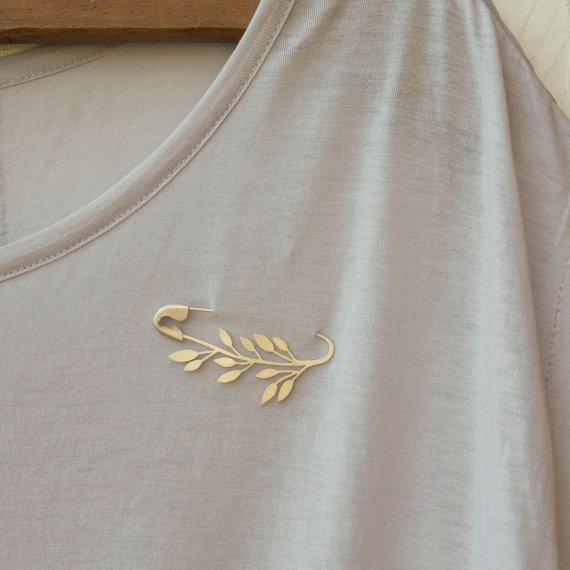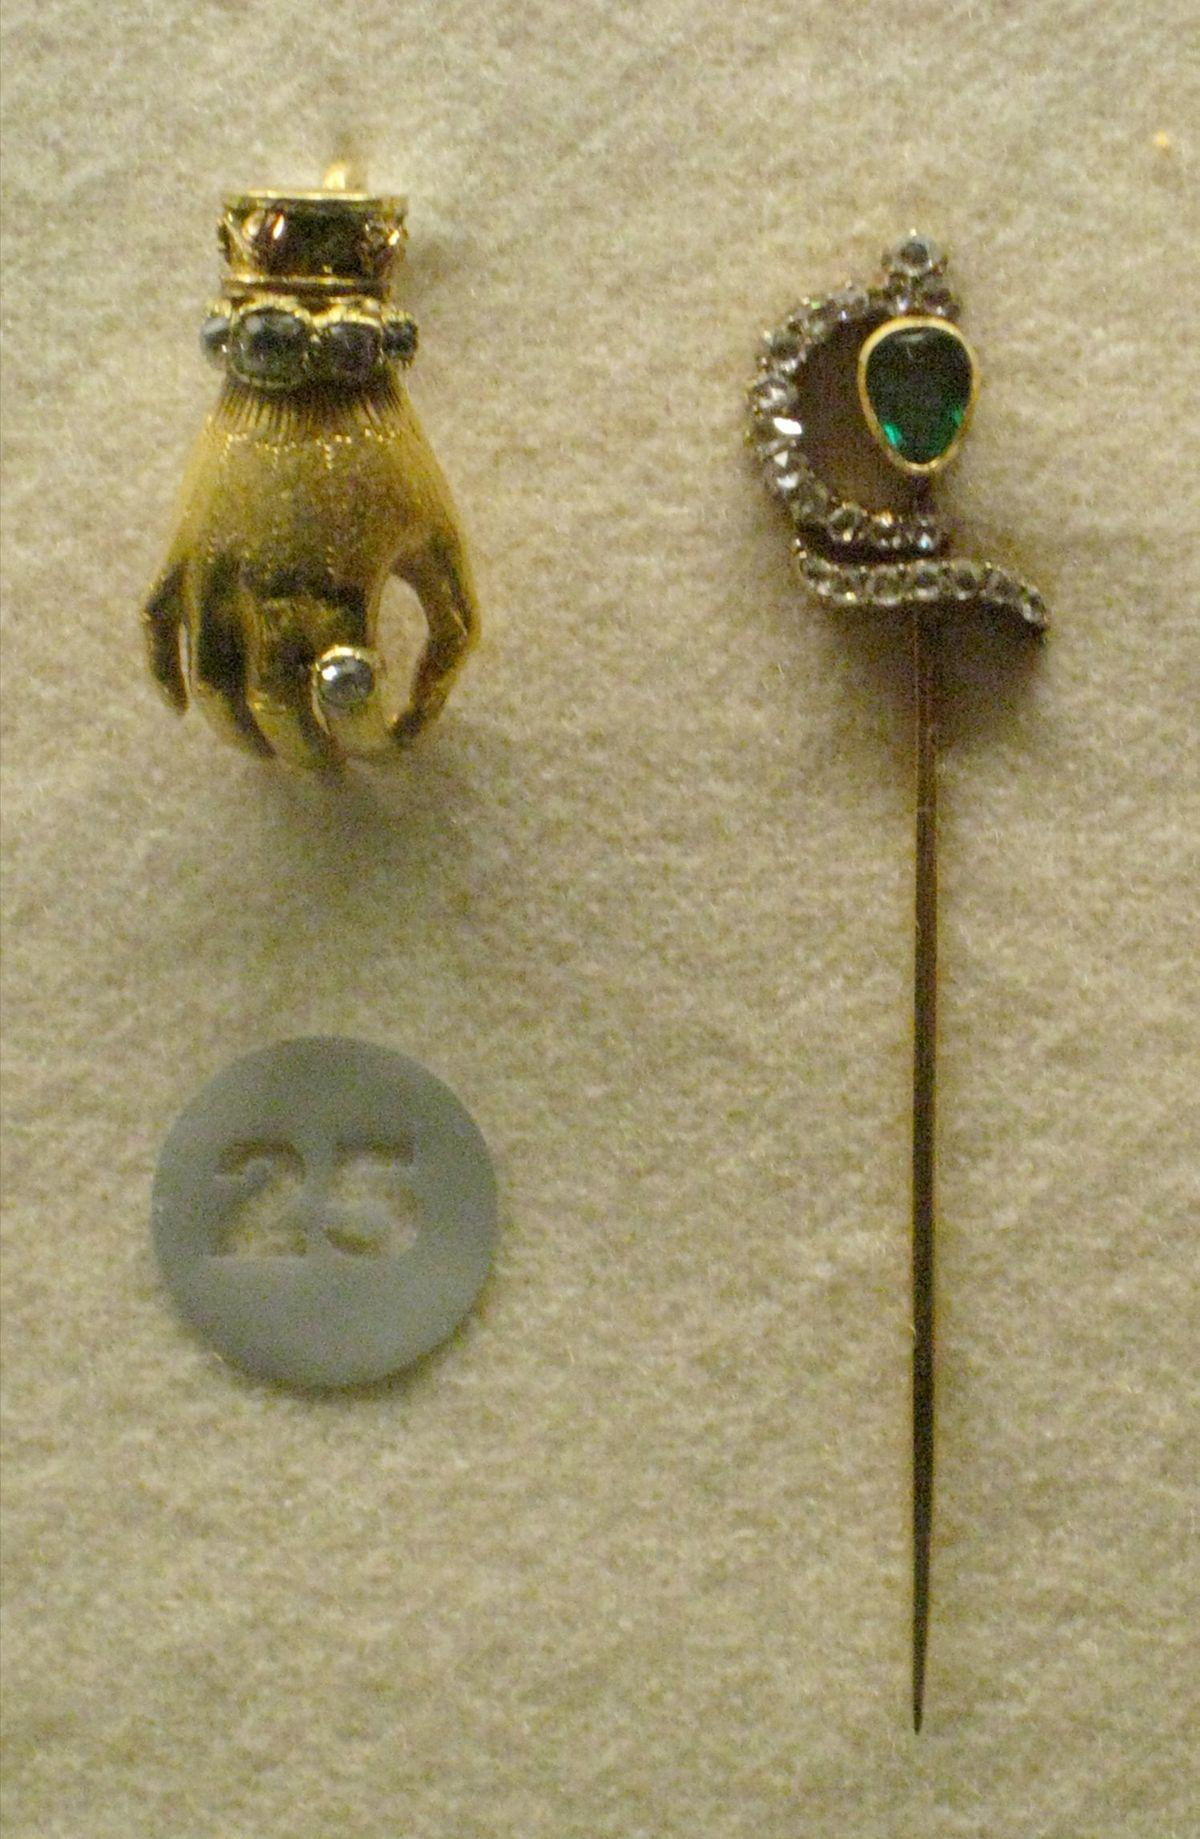The first image is the image on the left, the second image is the image on the right. Analyze the images presented: Is the assertion "The image to the left has a fabric background." valid? Answer yes or no. Yes. 